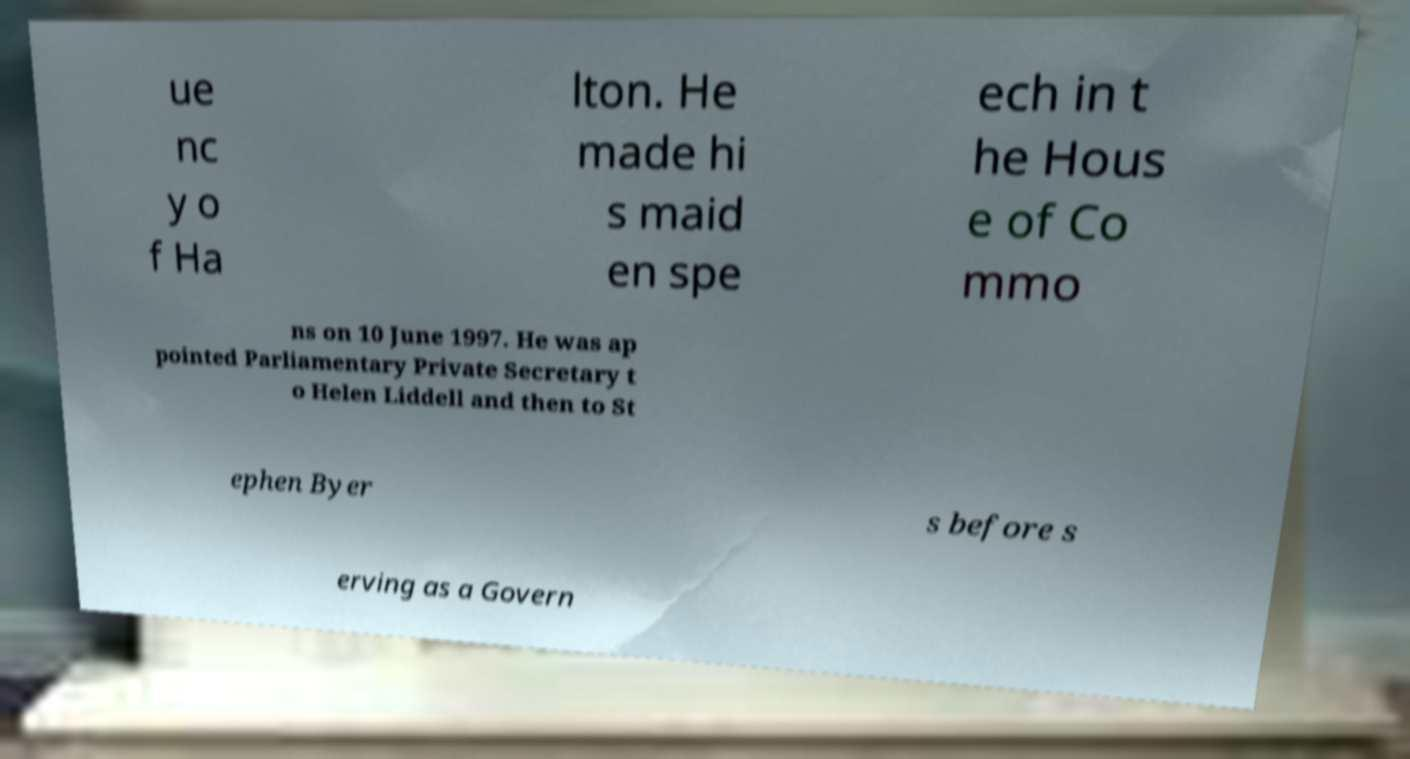Can you accurately transcribe the text from the provided image for me? ue nc y o f Ha lton. He made hi s maid en spe ech in t he Hous e of Co mmo ns on 10 June 1997. He was ap pointed Parliamentary Private Secretary t o Helen Liddell and then to St ephen Byer s before s erving as a Govern 